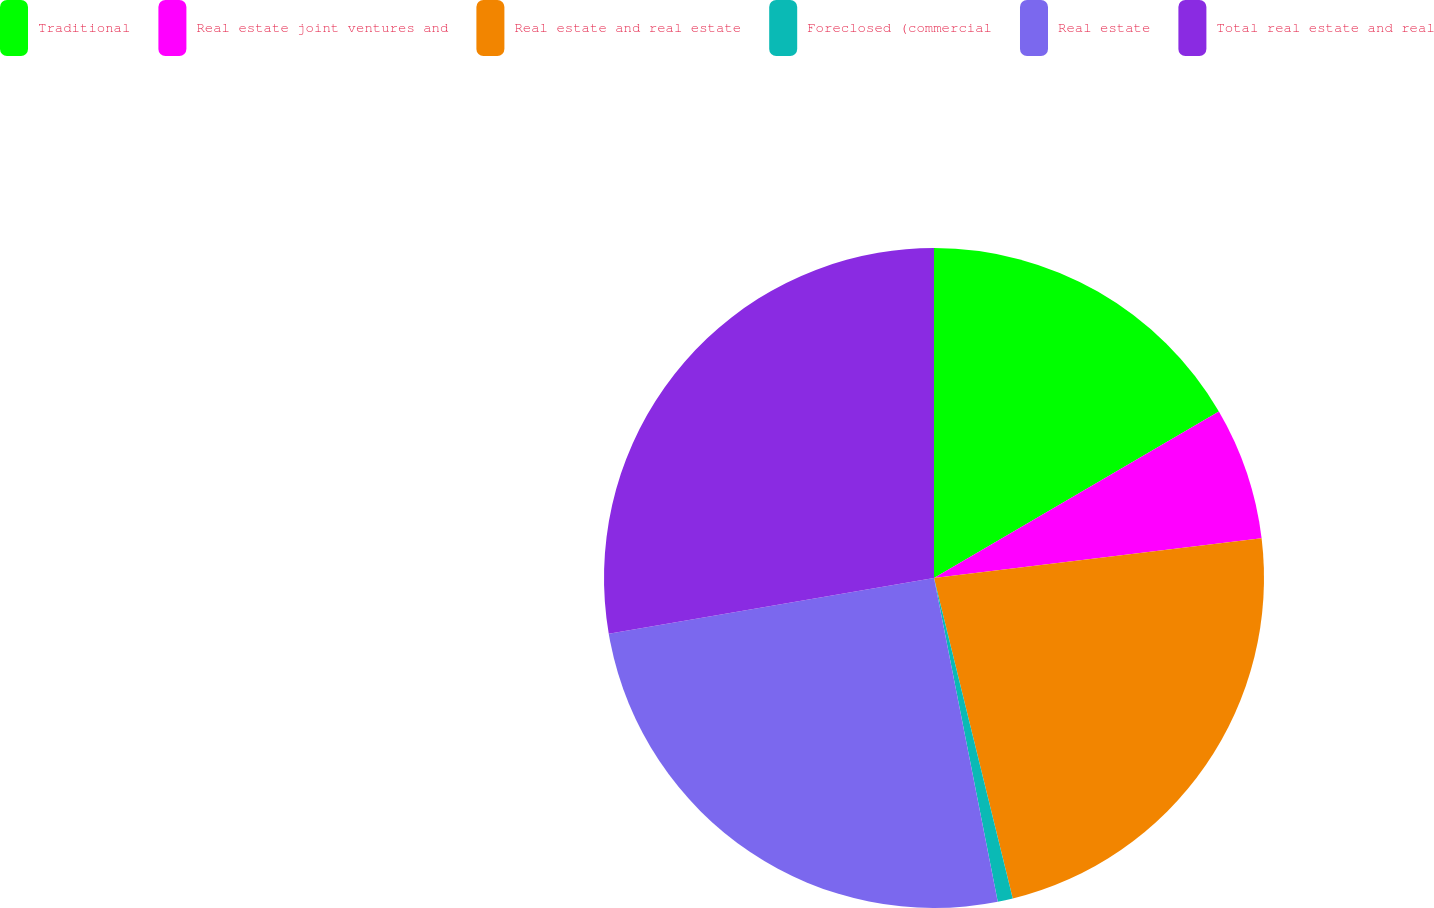Convert chart to OTSL. <chart><loc_0><loc_0><loc_500><loc_500><pie_chart><fcel>Traditional<fcel>Real estate joint ventures and<fcel>Real estate and real estate<fcel>Foreclosed (commercial<fcel>Real estate<fcel>Total real estate and real<nl><fcel>16.58%<fcel>6.5%<fcel>23.08%<fcel>0.74%<fcel>25.39%<fcel>27.7%<nl></chart> 